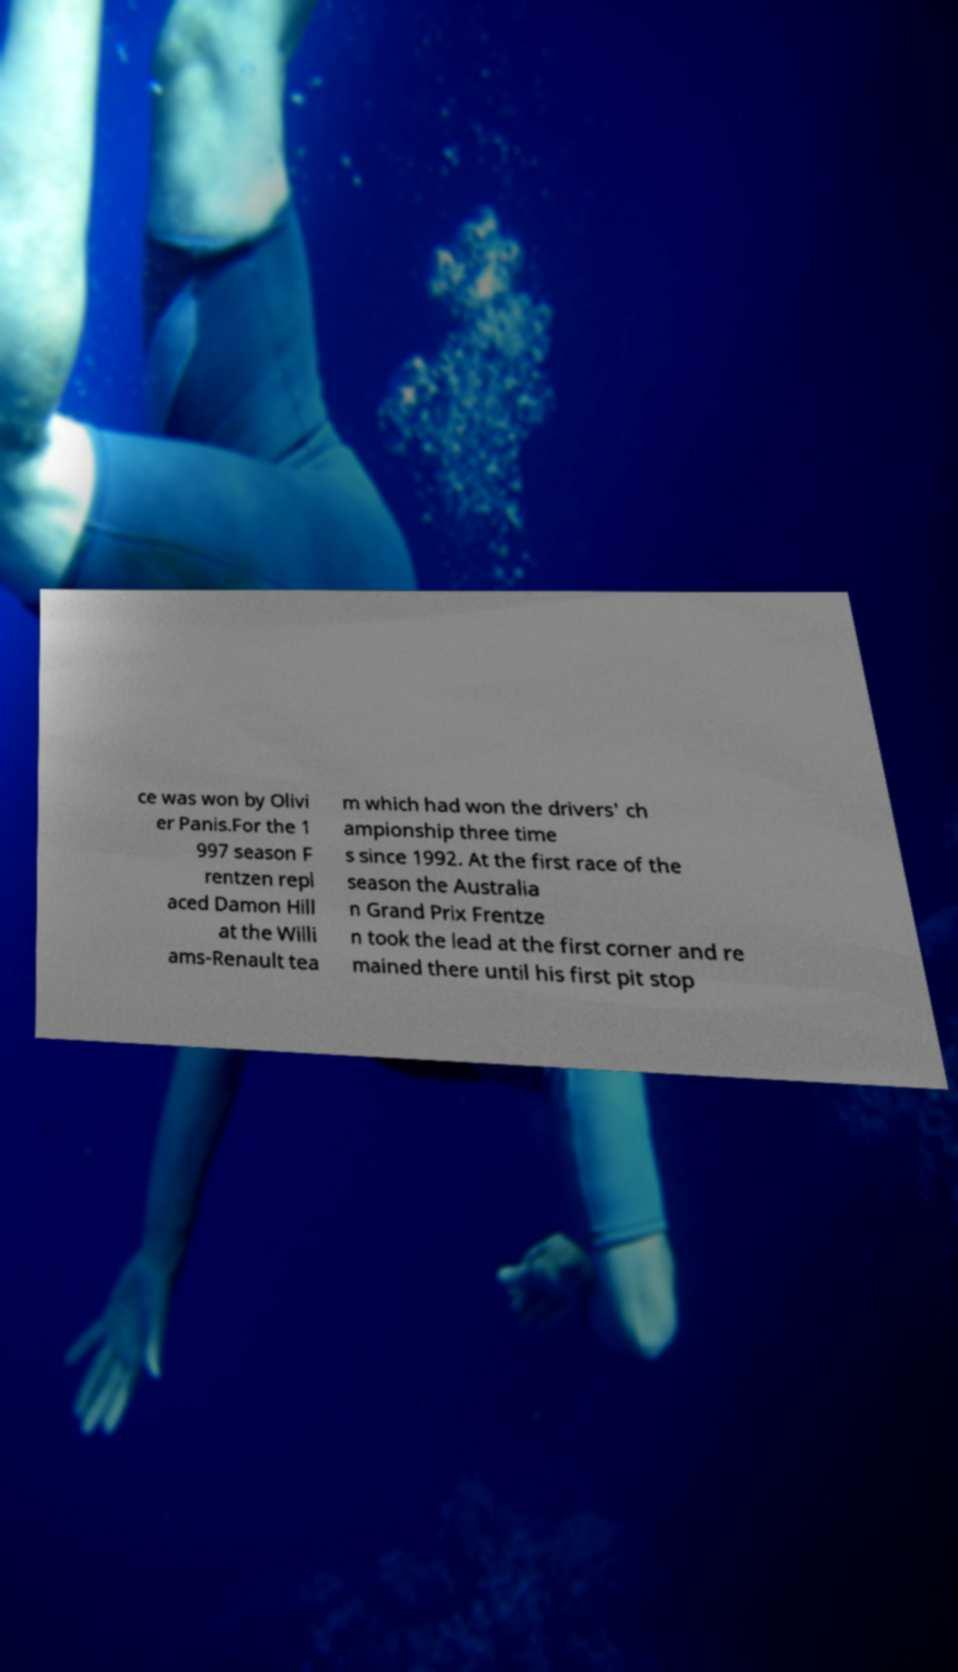Could you extract and type out the text from this image? ce was won by Olivi er Panis.For the 1 997 season F rentzen repl aced Damon Hill at the Willi ams-Renault tea m which had won the drivers' ch ampionship three time s since 1992. At the first race of the season the Australia n Grand Prix Frentze n took the lead at the first corner and re mained there until his first pit stop 